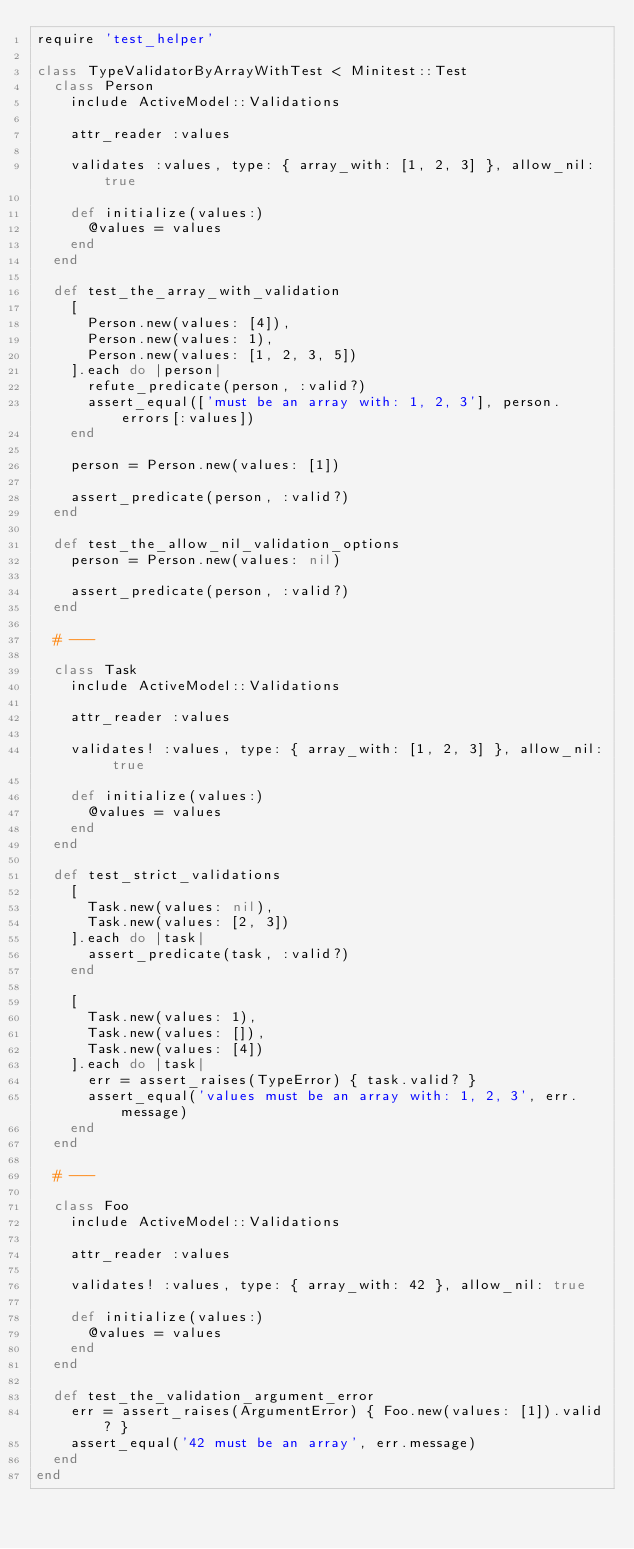Convert code to text. <code><loc_0><loc_0><loc_500><loc_500><_Ruby_>require 'test_helper'

class TypeValidatorByArrayWithTest < Minitest::Test
  class Person
    include ActiveModel::Validations

    attr_reader :values

    validates :values, type: { array_with: [1, 2, 3] }, allow_nil: true

    def initialize(values:)
      @values = values
    end
  end

  def test_the_array_with_validation
    [
      Person.new(values: [4]),
      Person.new(values: 1),
      Person.new(values: [1, 2, 3, 5])
    ].each do |person|
      refute_predicate(person, :valid?)
      assert_equal(['must be an array with: 1, 2, 3'], person.errors[:values])
    end

    person = Person.new(values: [1])

    assert_predicate(person, :valid?)
  end

  def test_the_allow_nil_validation_options
    person = Person.new(values: nil)

    assert_predicate(person, :valid?)
  end

  # ---

  class Task
    include ActiveModel::Validations

    attr_reader :values

    validates! :values, type: { array_with: [1, 2, 3] }, allow_nil: true

    def initialize(values:)
      @values = values
    end
  end

  def test_strict_validations
    [
      Task.new(values: nil),
      Task.new(values: [2, 3])
    ].each do |task|
      assert_predicate(task, :valid?)
    end

    [
      Task.new(values: 1),
      Task.new(values: []),
      Task.new(values: [4])
    ].each do |task|
      err = assert_raises(TypeError) { task.valid? }
      assert_equal('values must be an array with: 1, 2, 3', err.message)
    end
  end

  # ---

  class Foo
    include ActiveModel::Validations

    attr_reader :values

    validates! :values, type: { array_with: 42 }, allow_nil: true

    def initialize(values:)
      @values = values
    end
  end

  def test_the_validation_argument_error
    err = assert_raises(ArgumentError) { Foo.new(values: [1]).valid? }
    assert_equal('42 must be an array', err.message)
  end
end
</code> 